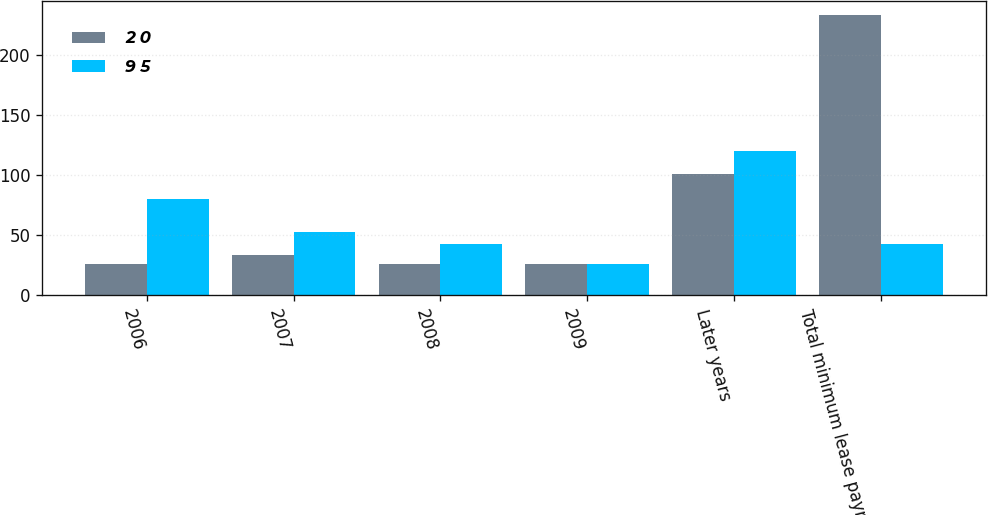<chart> <loc_0><loc_0><loc_500><loc_500><stacked_bar_chart><ecel><fcel>2006<fcel>2007<fcel>2008<fcel>2009<fcel>Later years<fcel>Total minimum lease payments<nl><fcel>2 0<fcel>26<fcel>34<fcel>26<fcel>26<fcel>101<fcel>233<nl><fcel>9 5<fcel>80<fcel>53<fcel>43<fcel>26<fcel>120<fcel>43<nl></chart> 